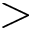Convert formula to latex. <formula><loc_0><loc_0><loc_500><loc_500>></formula> 